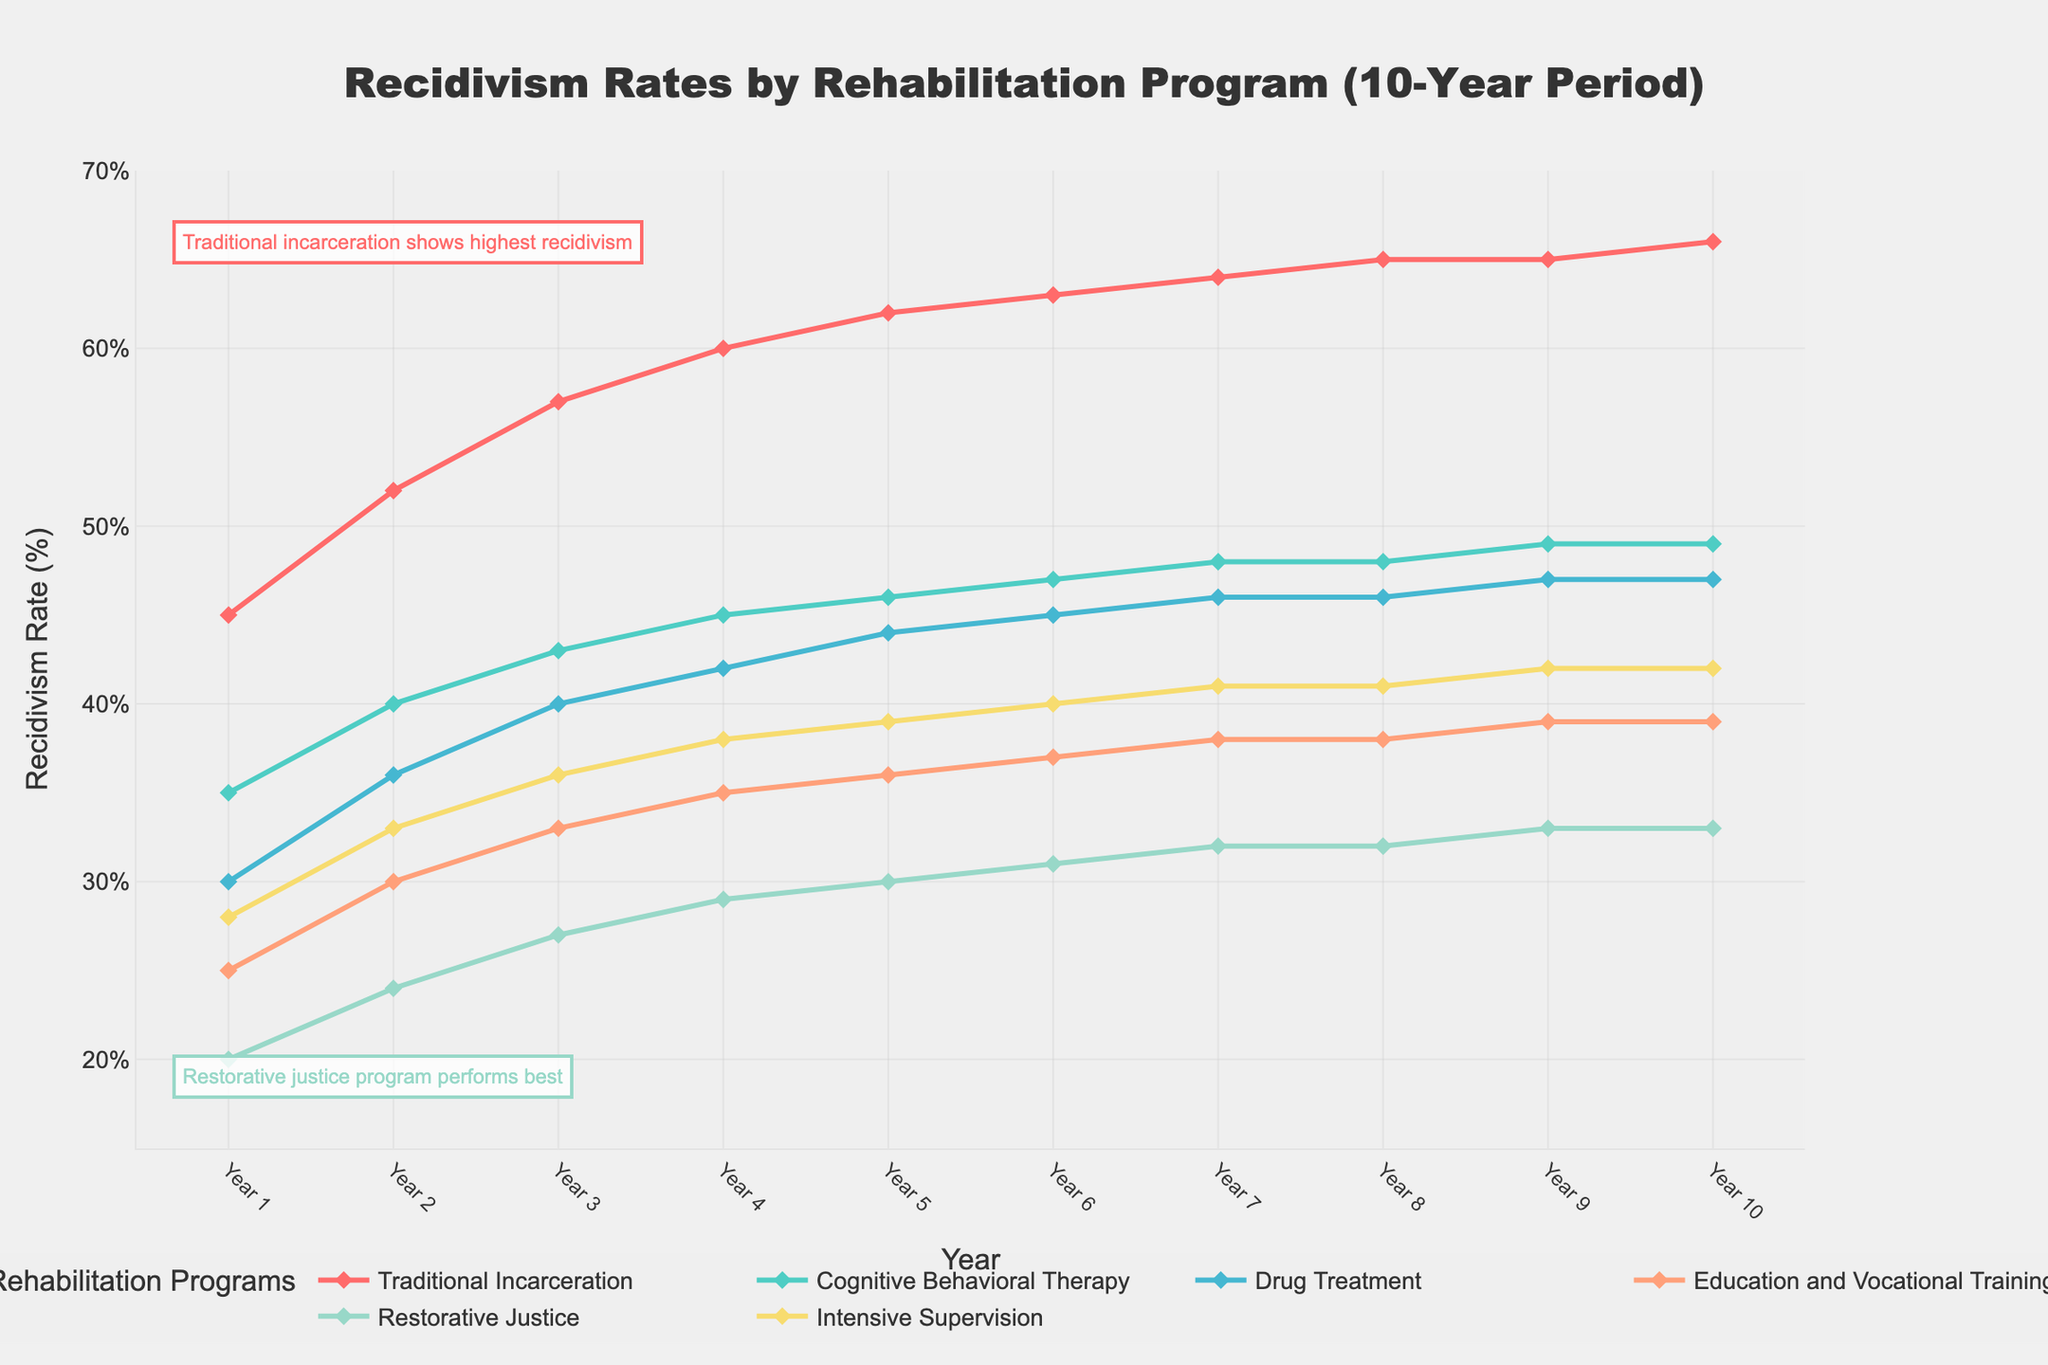What trend can be observed in the recidivism rates for Traditional Incarceration over the 10-year period? The figure shows that the recidivism rates for Traditional Incarceration consistently rise each year. Starting at 45% in Year 1, it increases every year and peaks at 66% in Year 10. This indicates a steady upward trend.
Answer: Steadily increasing trend Which rehabilitation program has the lowest recidivism rate throughout the 10-year period? Restorative Justice maintains the lowest recidivism rates throughout the 10-year period. Starting at 20% in Year 1 and rising to 33% by Year 10, it consistently has lower values compared to other programs.
Answer: Restorative Justice In Year 5, how do the recidivism rates of Cognitive Behavioral Therapy and Education and Vocational Training compare? In Year 5, the recidivism rate for Cognitive Behavioral Therapy is 46%, whereas for Education and Vocational Training, it is 36%. Cognitive Behavioral Therapy has a higher recidivism rate than Education and Vocational Training by 10 percentage points.
Answer: Cognitive Behavioral Therapy is higher by 10% What is the average recidivism rate for Drug Treatment over the 10-year period? To find the average, sum the recidivism rates for Drug Treatment over the 10 years (30 + 36 + 40 + 42 + 44 + 45 + 46 + 46 + 47 + 47 = 423) and then divide by 10. The average is 423/10 = 42.3%.
Answer: 42.3% During which years does the Intensive Supervision program show no change in recidivism rates? The figure indicates that the recidivism rate for Intensive Supervision remains constant at 41% in both Year 7 and Year 8, and again at 42% in both Year 9 and Year 10. Therefore, there are no changes during these years.
Answer: Year 7 to Year 8, Year 9 to Year 10 What can be inferred about the effectiveness of the Restorative Justice program in comparison to Traditional Incarceration based on the overall trends? Traditional Incarceration shows a constantly increasing recidivism rate, peaking at 66% in Year 10, while Restorative Justice starts at a lower rate of 20% and rises modestly to 33%. This suggests that Restorative Justice is more effective in reducing recidivism rates compared to Traditional Incarceration.
Answer: Restorative Justice is more effective Which program shows the smallest change in recidivism rate from Year 1 to Year 10? By evaluating the changes, Restorative Justice changes from 20% in Year 1 to 33% in Year 10, a difference of 13 percentage points, which is the smallest increase compared to other programs.
Answer: Restorative Justice How do the recidivism rates of all programs compare in Year 10? In Year 10, the recidivism rates are as follows: Traditional Incarceration at 66%, Cognitive Behavioral Therapy at 49%, Drug Treatment at 47%, Education and Vocational Training at 39%, Restorative Justice at 33%, and Intensive Supervision at 42%. Traditional Incarceration has the highest rate, while Restorative Justice has the lowest.
Answer: Traditional Incarceration highest, Restorative Justice lowest 